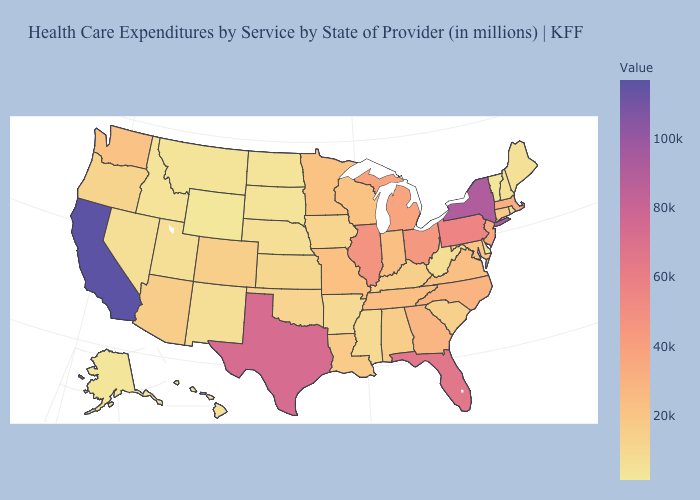Does Vermont have the lowest value in the Northeast?
Quick response, please. Yes. Among the states that border Arizona , does Utah have the highest value?
Write a very short answer. No. Does North Dakota have the lowest value in the MidWest?
Keep it brief. Yes. 